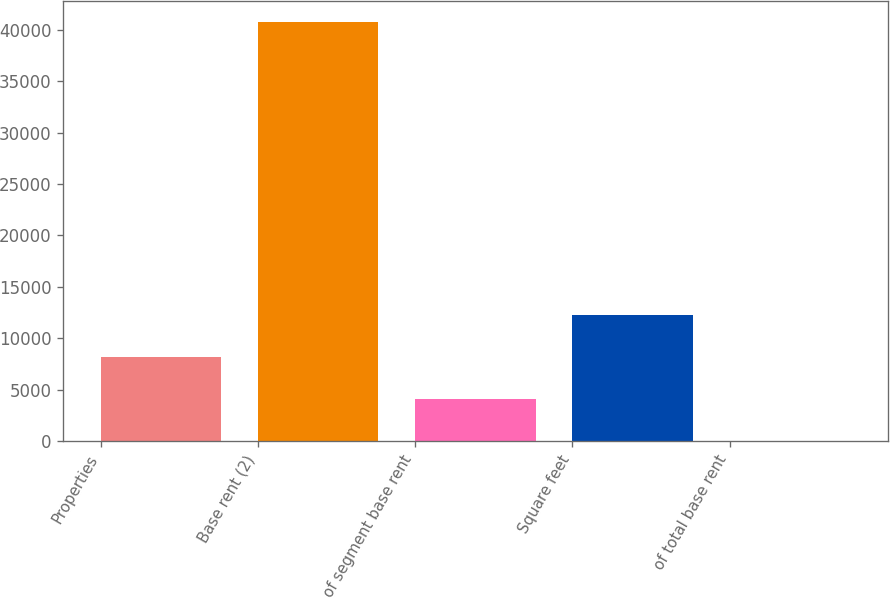<chart> <loc_0><loc_0><loc_500><loc_500><bar_chart><fcel>Properties<fcel>Base rent (2)<fcel>of segment base rent<fcel>Square feet<fcel>of total base rent<nl><fcel>8161<fcel>40753<fcel>4087<fcel>12235<fcel>13<nl></chart> 